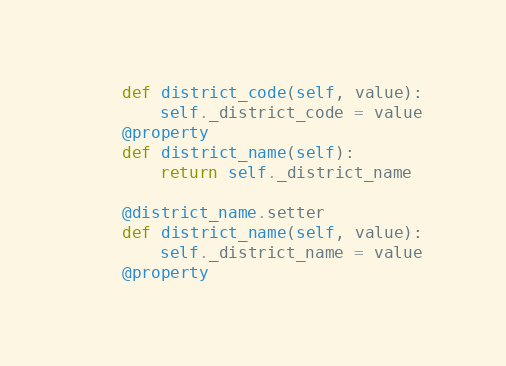Convert code to text. <code><loc_0><loc_0><loc_500><loc_500><_Python_>    def district_code(self, value):
        self._district_code = value
    @property
    def district_name(self):
        return self._district_name

    @district_name.setter
    def district_name(self, value):
        self._district_name = value
    @property</code> 